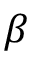<formula> <loc_0><loc_0><loc_500><loc_500>\beta</formula> 